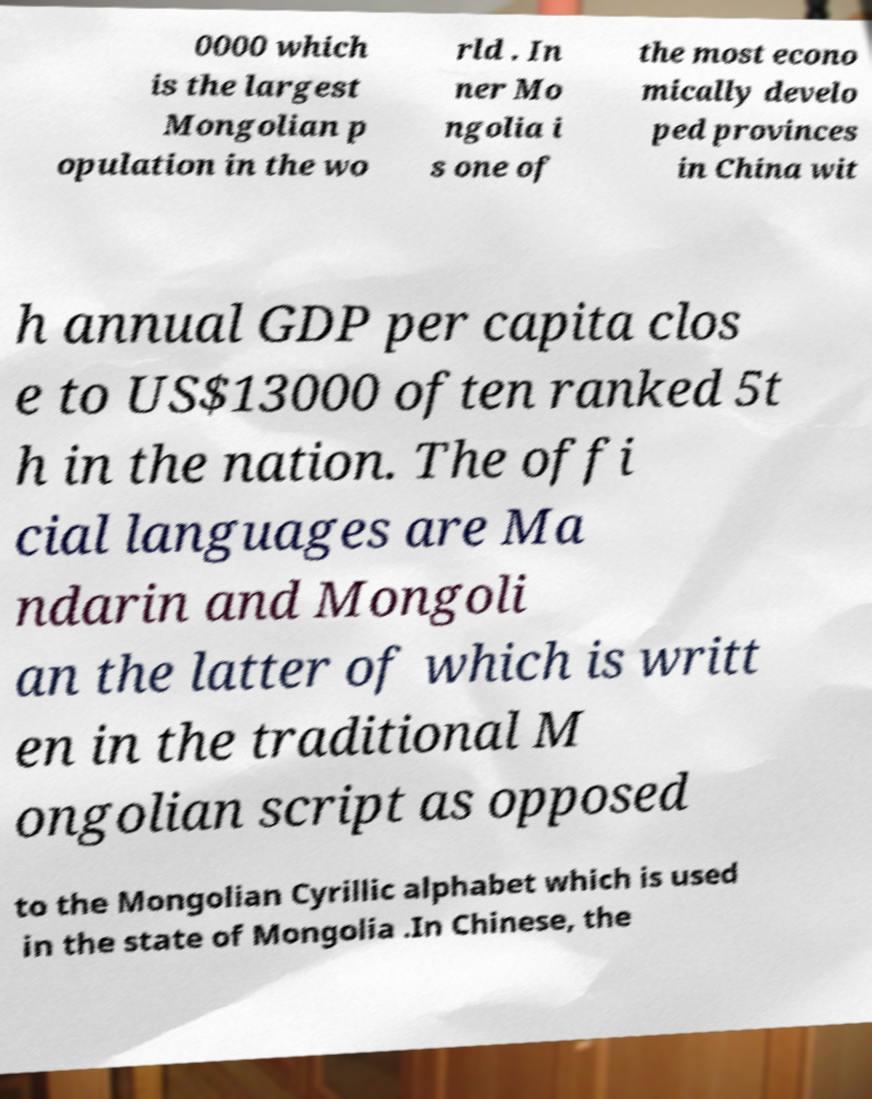Could you extract and type out the text from this image? 0000 which is the largest Mongolian p opulation in the wo rld . In ner Mo ngolia i s one of the most econo mically develo ped provinces in China wit h annual GDP per capita clos e to US$13000 often ranked 5t h in the nation. The offi cial languages are Ma ndarin and Mongoli an the latter of which is writt en in the traditional M ongolian script as opposed to the Mongolian Cyrillic alphabet which is used in the state of Mongolia .In Chinese, the 